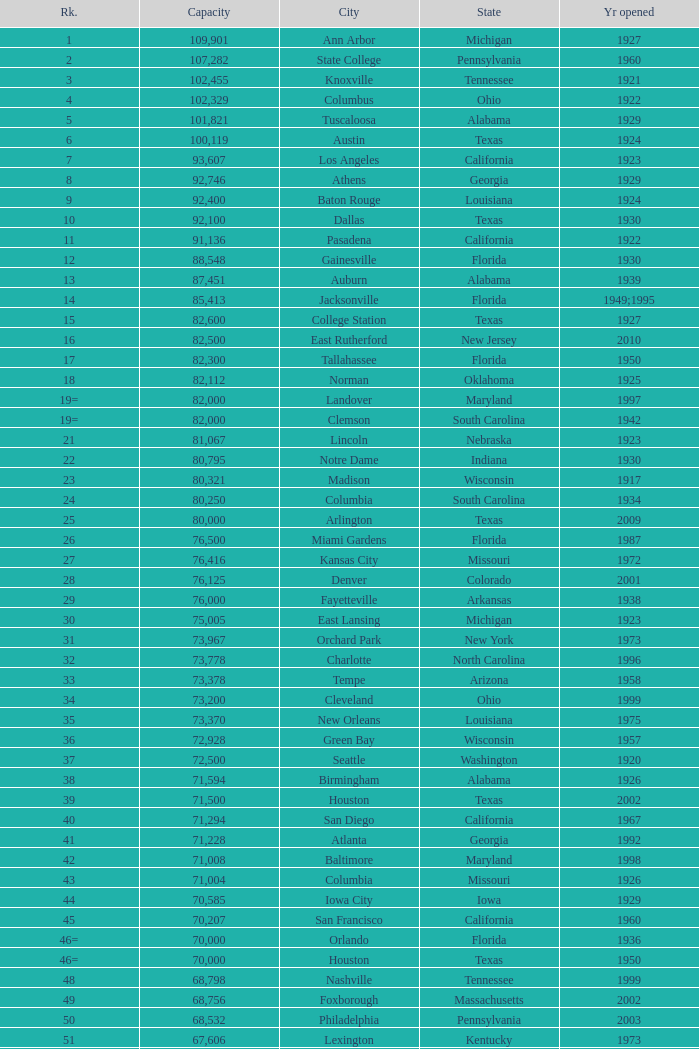What is the rank for the year opened in 1959 in Pennsylvania? 134=. 